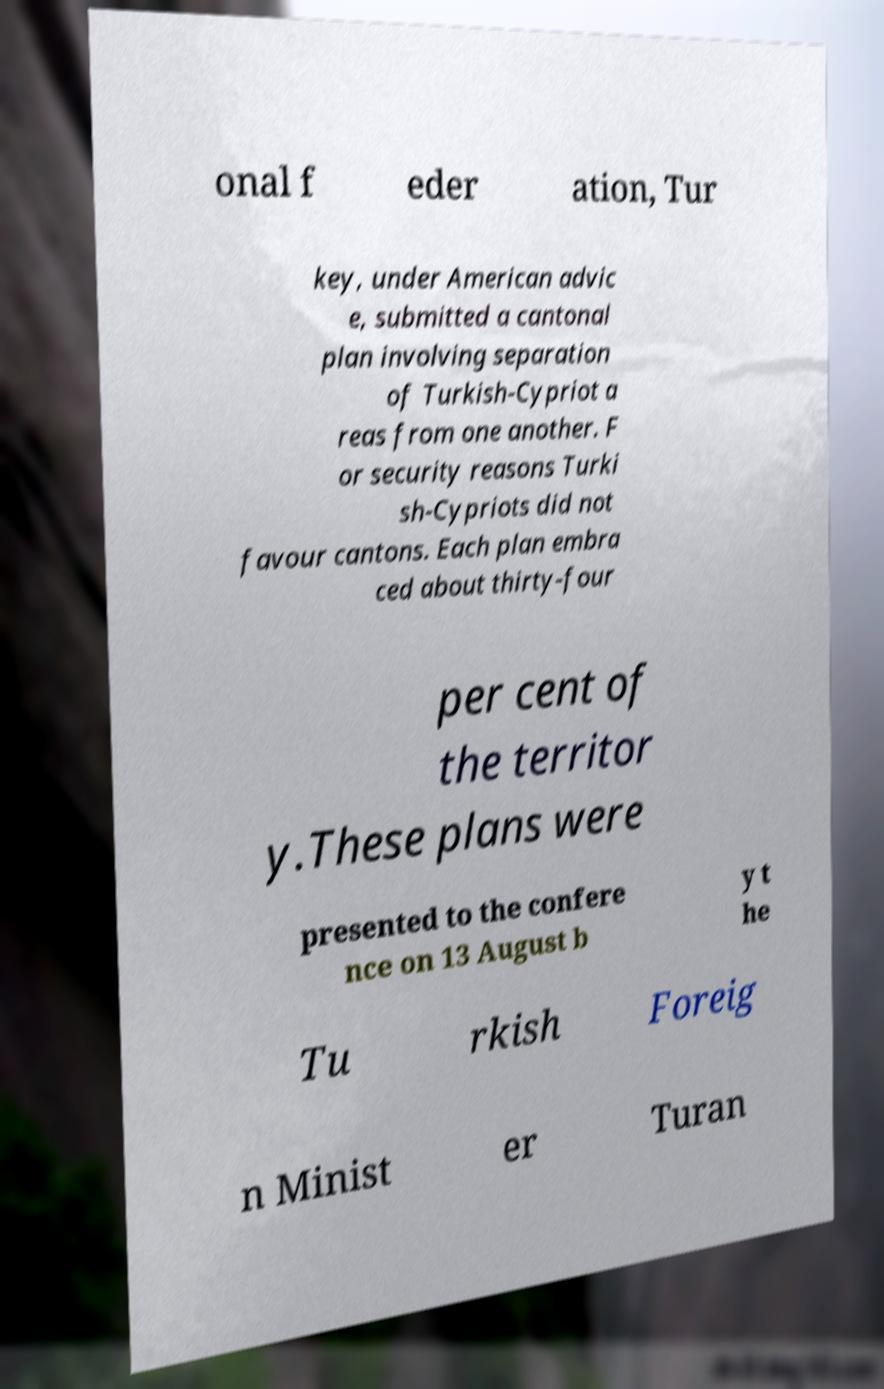Please read and relay the text visible in this image. What does it say? onal f eder ation, Tur key, under American advic e, submitted a cantonal plan involving separation of Turkish-Cypriot a reas from one another. F or security reasons Turki sh-Cypriots did not favour cantons. Each plan embra ced about thirty-four per cent of the territor y.These plans were presented to the confere nce on 13 August b y t he Tu rkish Foreig n Minist er Turan 